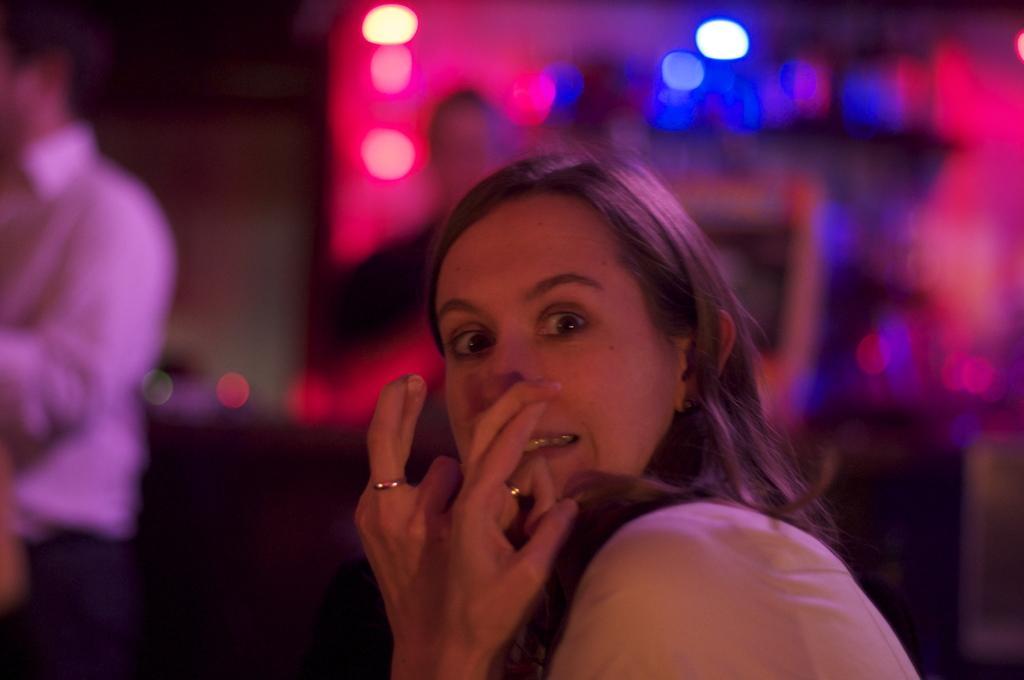In one or two sentences, can you explain what this image depicts? In this picture there is a woman standing and giving a pose into the camera. Behind there is a blur background with some colorful spotlights. 